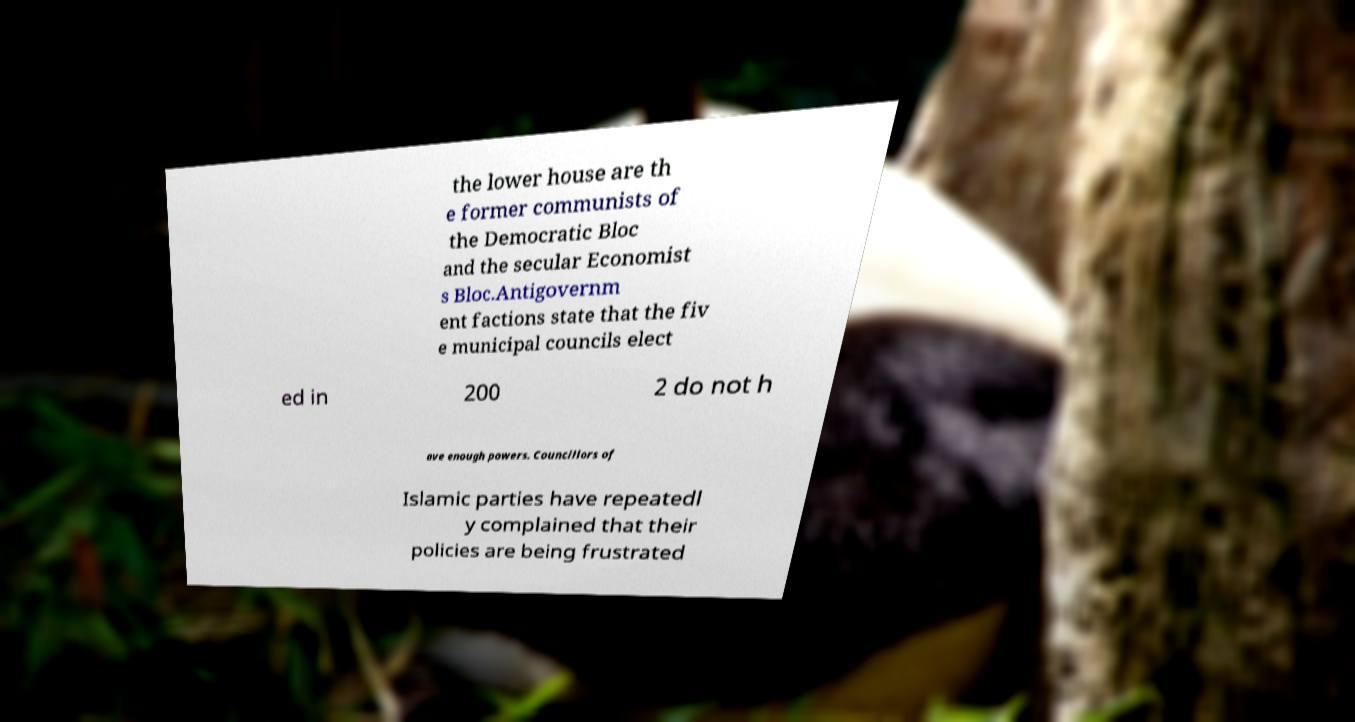Can you read and provide the text displayed in the image?This photo seems to have some interesting text. Can you extract and type it out for me? the lower house are th e former communists of the Democratic Bloc and the secular Economist s Bloc.Antigovernm ent factions state that the fiv e municipal councils elect ed in 200 2 do not h ave enough powers. Councillors of Islamic parties have repeatedl y complained that their policies are being frustrated 